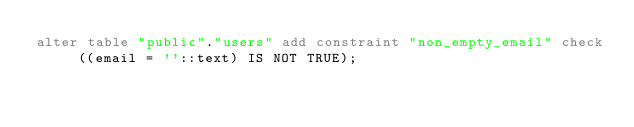<code> <loc_0><loc_0><loc_500><loc_500><_SQL_>alter table "public"."users" add constraint "non_empty_email" check ((email = ''::text) IS NOT TRUE);
</code> 